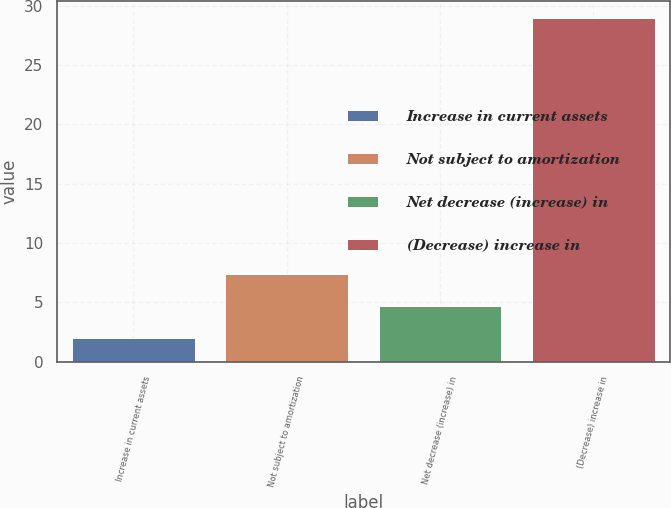Convert chart. <chart><loc_0><loc_0><loc_500><loc_500><bar_chart><fcel>Increase in current assets<fcel>Not subject to amortization<fcel>Net decrease (increase) in<fcel>(Decrease) increase in<nl><fcel>2<fcel>7.4<fcel>4.7<fcel>29<nl></chart> 